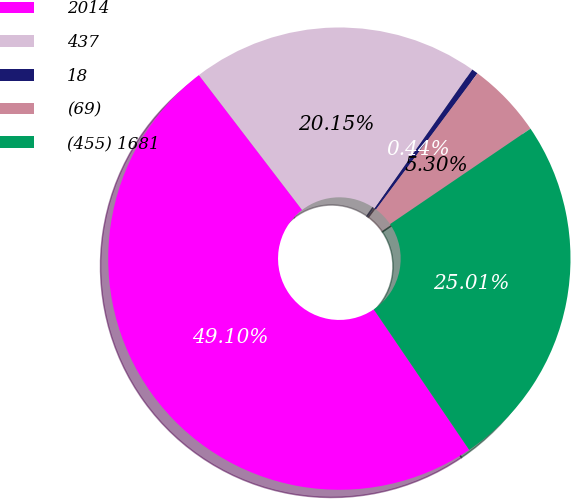<chart> <loc_0><loc_0><loc_500><loc_500><pie_chart><fcel>2014<fcel>437<fcel>18<fcel>(69)<fcel>(455) 1681<nl><fcel>49.1%<fcel>20.15%<fcel>0.44%<fcel>5.3%<fcel>25.01%<nl></chart> 